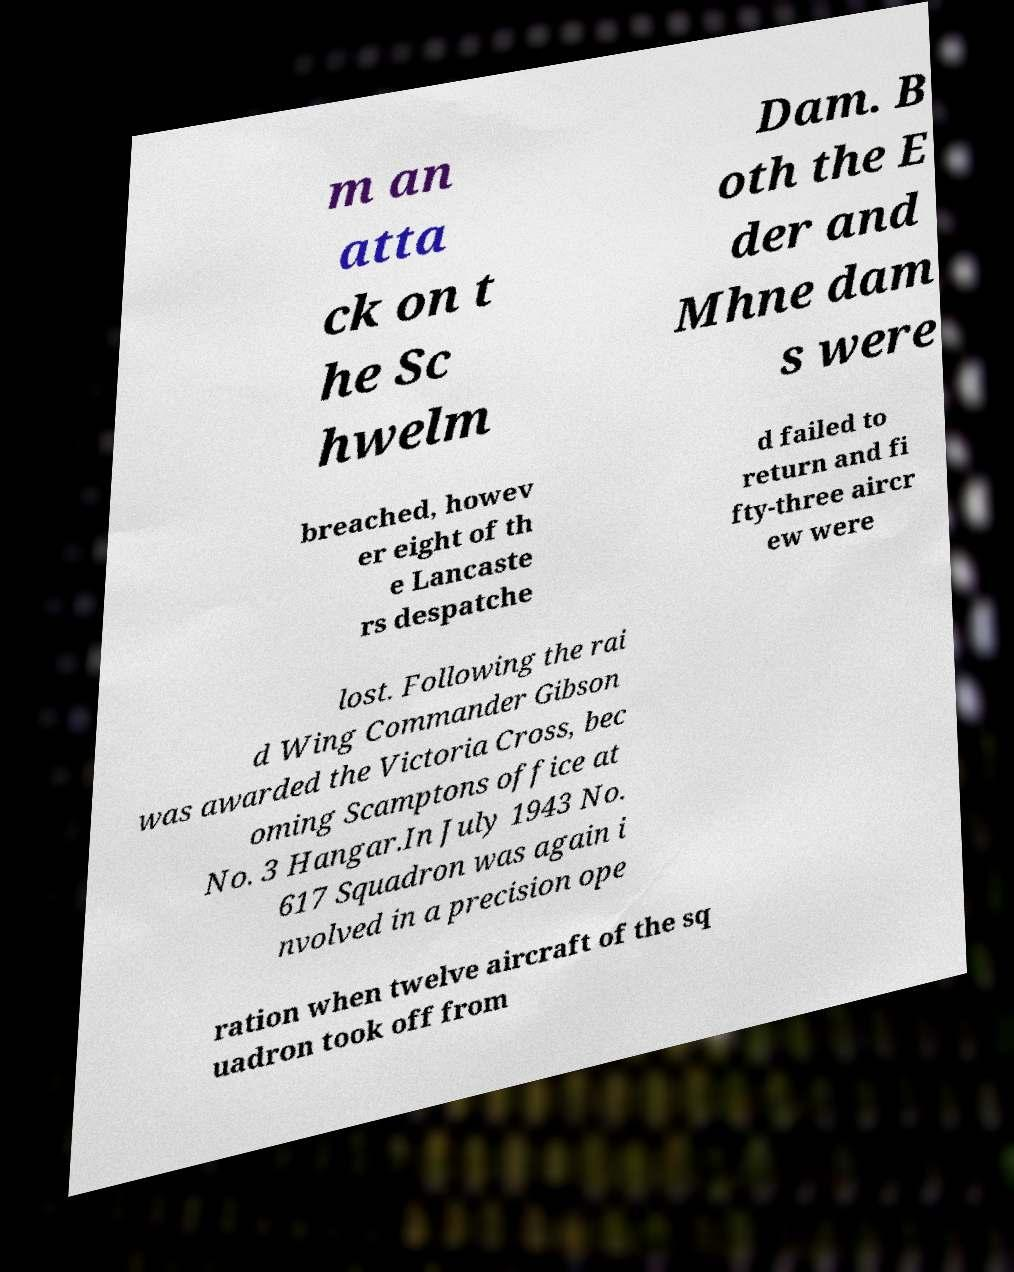I need the written content from this picture converted into text. Can you do that? m an atta ck on t he Sc hwelm Dam. B oth the E der and Mhne dam s were breached, howev er eight of th e Lancaste rs despatche d failed to return and fi fty-three aircr ew were lost. Following the rai d Wing Commander Gibson was awarded the Victoria Cross, bec oming Scamptons office at No. 3 Hangar.In July 1943 No. 617 Squadron was again i nvolved in a precision ope ration when twelve aircraft of the sq uadron took off from 